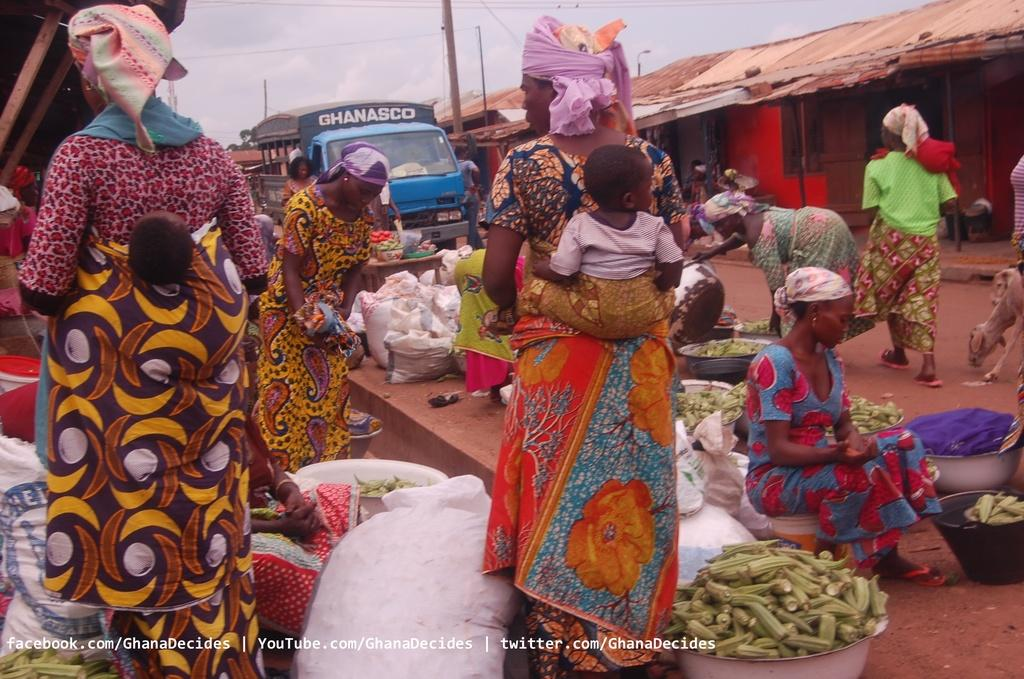What is the main object on the ground in the image? There is a vehicle on the ground in the image. What type of structures can be seen in the image? There are huts in the image. What items are present in the baskets in the image? The baskets contain vegetables in the image. How are the babies being carried by the people in the image? The people are carrying their babies at their backs in the image. What song is being sung by the leaves in the image? There are no leaves or singing in the image; it features a vehicle, huts, baskets with vegetables, and people carrying their babies. 